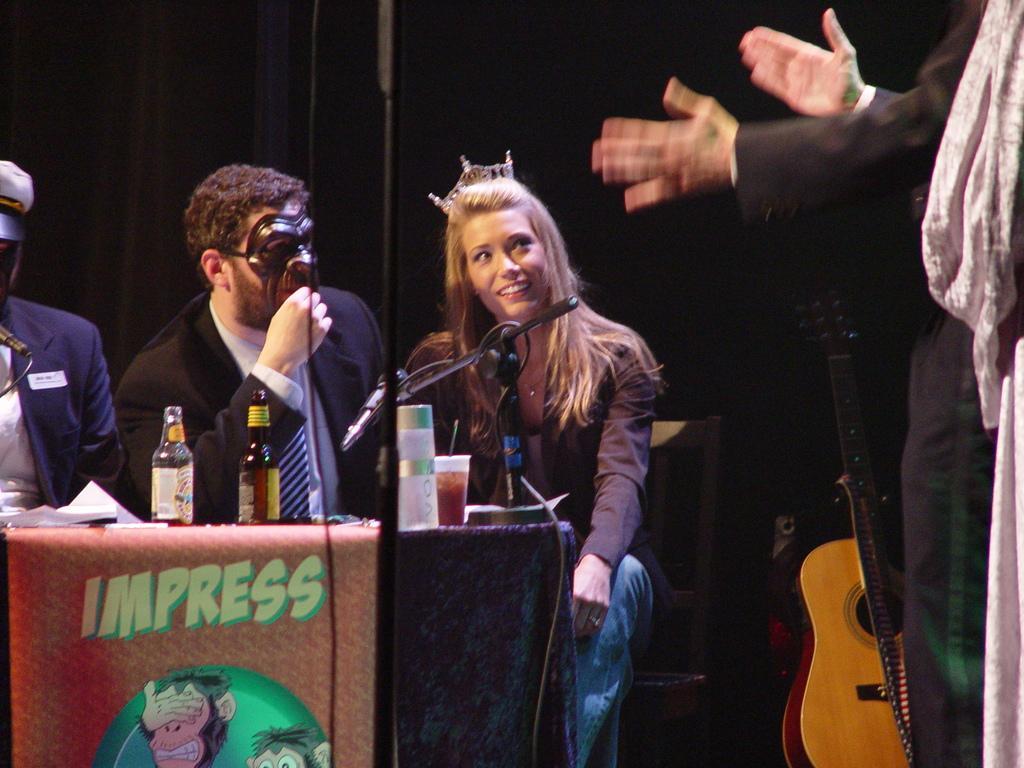Describe this image in one or two sentences. I can see in this image there are group of people are sitting on chair in front of a table. I can see few objects on the table and a guitar. 